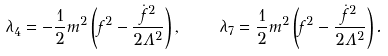Convert formula to latex. <formula><loc_0><loc_0><loc_500><loc_500>\lambda _ { 4 } = - \frac { 1 } { 2 } m ^ { 2 } \left ( f ^ { 2 } - \frac { { \dot { f } } ^ { 2 } } { 2 \Lambda ^ { 2 } } \right ) , \quad \lambda _ { 7 } = \frac { 1 } { 2 } m ^ { 2 } \left ( f ^ { 2 } - \frac { { \dot { f } } ^ { 2 } } { 2 \Lambda ^ { 2 } } \right ) .</formula> 